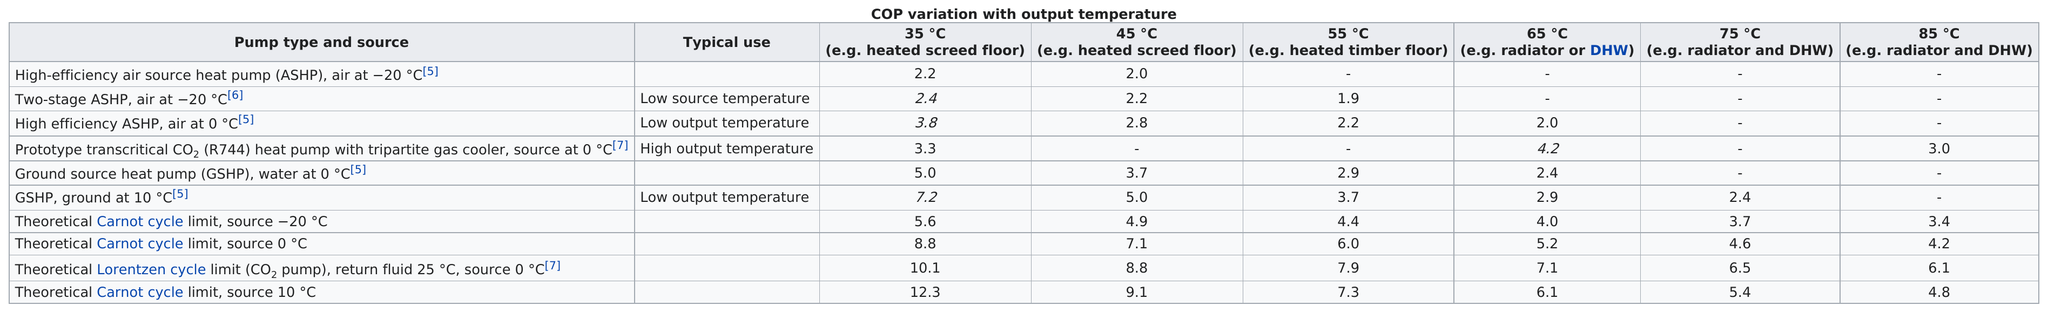Give some essential details in this illustration. The average variation when using ground source heat pump water at 0 degrees is 3.5. GSHP data is available in a digital format, and ground at 10 degrees latitude is located near low output temperature or high output temperature, depending on the type of temperature data. The Carnot cycle limit for a theoretical pump was calculated to be 35 degrees Celsius, with a source temperature of 10 degrees Celsius. Two-stage air conditioning systems have less variability at 55°C compared to other pump types, as evidenced by a study conducted at 6°C air temperature. According to the theoretical LORENTZEN cycle, the coefficient of performance (COP) variation at 45°Celsius is the same as what other pump at 35°Celsius. Additionally, the theoretical Carnot cycle limit, with a source temperature of 0°Celsius, was used to make this comparison. 